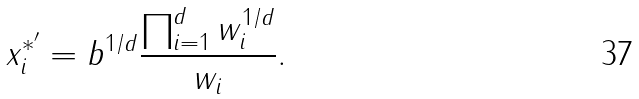<formula> <loc_0><loc_0><loc_500><loc_500>x _ { i } ^ { * ^ { \prime } } = b ^ { 1 / d } \frac { \prod _ { i = 1 } ^ { d } w _ { i } ^ { 1 / d } } { w _ { i } } .</formula> 